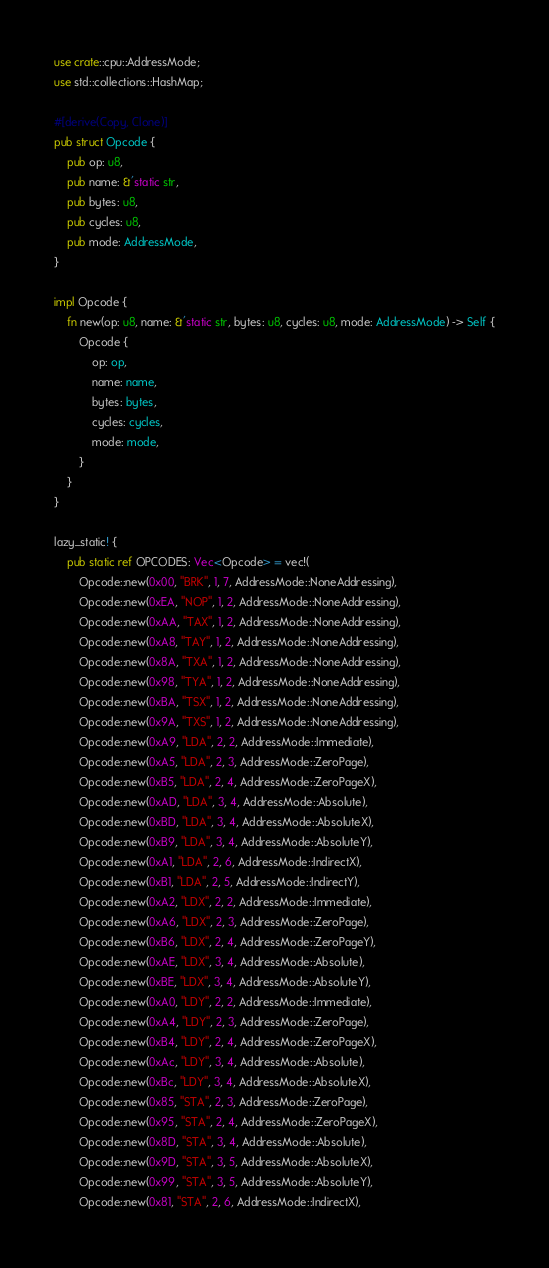Convert code to text. <code><loc_0><loc_0><loc_500><loc_500><_Rust_>use crate::cpu::AddressMode;
use std::collections::HashMap;

#[derive(Copy, Clone)]
pub struct Opcode {
    pub op: u8,
    pub name: &'static str,
    pub bytes: u8,
    pub cycles: u8,
    pub mode: AddressMode,
}

impl Opcode {
    fn new(op: u8, name: &'static str, bytes: u8, cycles: u8, mode: AddressMode) -> Self {
        Opcode {
            op: op,
            name: name,
            bytes: bytes,
            cycles: cycles,
            mode: mode,
        }
    }
}

lazy_static! {
    pub static ref OPCODES: Vec<Opcode> = vec!(
        Opcode::new(0x00, "BRK", 1, 7, AddressMode::NoneAddressing),
        Opcode::new(0xEA, "NOP", 1, 2, AddressMode::NoneAddressing),
        Opcode::new(0xAA, "TAX", 1, 2, AddressMode::NoneAddressing),
        Opcode::new(0xA8, "TAY", 1, 2, AddressMode::NoneAddressing),
        Opcode::new(0x8A, "TXA", 1, 2, AddressMode::NoneAddressing),
        Opcode::new(0x98, "TYA", 1, 2, AddressMode::NoneAddressing),
        Opcode::new(0xBA, "TSX", 1, 2, AddressMode::NoneAddressing),
        Opcode::new(0x9A, "TXS", 1, 2, AddressMode::NoneAddressing),
        Opcode::new(0xA9, "LDA", 2, 2, AddressMode::Immediate),
        Opcode::new(0xA5, "LDA", 2, 3, AddressMode::ZeroPage),
        Opcode::new(0xB5, "LDA", 2, 4, AddressMode::ZeroPageX),
        Opcode::new(0xAD, "LDA", 3, 4, AddressMode::Absolute),
        Opcode::new(0xBD, "LDA", 3, 4, AddressMode::AbsoluteX),
        Opcode::new(0xB9, "LDA", 3, 4, AddressMode::AbsoluteY),
        Opcode::new(0xA1, "LDA", 2, 6, AddressMode::IndirectX),
        Opcode::new(0xB1, "LDA", 2, 5, AddressMode::IndirectY),
        Opcode::new(0xA2, "LDX", 2, 2, AddressMode::Immediate),
        Opcode::new(0xA6, "LDX", 2, 3, AddressMode::ZeroPage),
        Opcode::new(0xB6, "LDX", 2, 4, AddressMode::ZeroPageY),
        Opcode::new(0xAE, "LDX", 3, 4, AddressMode::Absolute),
        Opcode::new(0xBE, "LDX", 3, 4, AddressMode::AbsoluteY),
        Opcode::new(0xA0, "LDY", 2, 2, AddressMode::Immediate),
        Opcode::new(0xA4, "LDY", 2, 3, AddressMode::ZeroPage),
        Opcode::new(0xB4, "LDY", 2, 4, AddressMode::ZeroPageX),
        Opcode::new(0xAc, "LDY", 3, 4, AddressMode::Absolute),
        Opcode::new(0xBc, "LDY", 3, 4, AddressMode::AbsoluteX),
        Opcode::new(0x85, "STA", 2, 3, AddressMode::ZeroPage),
        Opcode::new(0x95, "STA", 2, 4, AddressMode::ZeroPageX),
        Opcode::new(0x8D, "STA", 3, 4, AddressMode::Absolute),
        Opcode::new(0x9D, "STA", 3, 5, AddressMode::AbsoluteX),
        Opcode::new(0x99, "STA", 3, 5, AddressMode::AbsoluteY),
        Opcode::new(0x81, "STA", 2, 6, AddressMode::IndirectX),</code> 